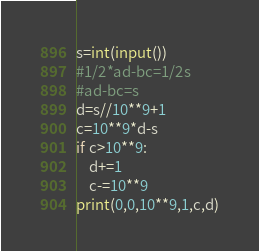Convert code to text. <code><loc_0><loc_0><loc_500><loc_500><_Python_>s=int(input())
#1/2*ad-bc=1/2s
#ad-bc=s
d=s//10**9+1
c=10**9*d-s
if c>10**9:
	d+=1
	c-=10**9
print(0,0,10**9,1,c,d)</code> 